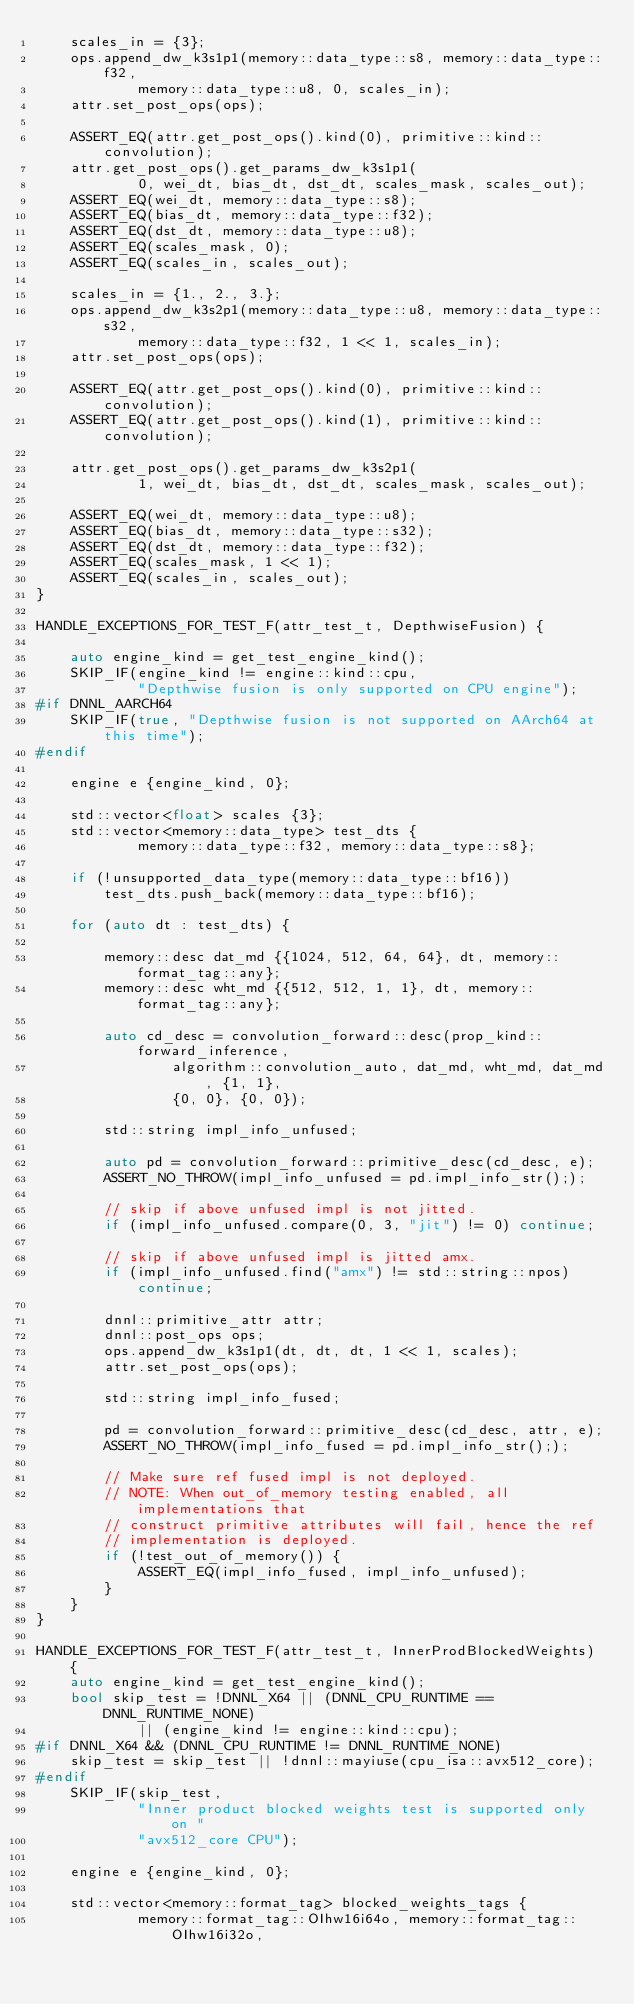Convert code to text. <code><loc_0><loc_0><loc_500><loc_500><_C++_>    scales_in = {3};
    ops.append_dw_k3s1p1(memory::data_type::s8, memory::data_type::f32,
            memory::data_type::u8, 0, scales_in);
    attr.set_post_ops(ops);

    ASSERT_EQ(attr.get_post_ops().kind(0), primitive::kind::convolution);
    attr.get_post_ops().get_params_dw_k3s1p1(
            0, wei_dt, bias_dt, dst_dt, scales_mask, scales_out);
    ASSERT_EQ(wei_dt, memory::data_type::s8);
    ASSERT_EQ(bias_dt, memory::data_type::f32);
    ASSERT_EQ(dst_dt, memory::data_type::u8);
    ASSERT_EQ(scales_mask, 0);
    ASSERT_EQ(scales_in, scales_out);

    scales_in = {1., 2., 3.};
    ops.append_dw_k3s2p1(memory::data_type::u8, memory::data_type::s32,
            memory::data_type::f32, 1 << 1, scales_in);
    attr.set_post_ops(ops);

    ASSERT_EQ(attr.get_post_ops().kind(0), primitive::kind::convolution);
    ASSERT_EQ(attr.get_post_ops().kind(1), primitive::kind::convolution);

    attr.get_post_ops().get_params_dw_k3s2p1(
            1, wei_dt, bias_dt, dst_dt, scales_mask, scales_out);

    ASSERT_EQ(wei_dt, memory::data_type::u8);
    ASSERT_EQ(bias_dt, memory::data_type::s32);
    ASSERT_EQ(dst_dt, memory::data_type::f32);
    ASSERT_EQ(scales_mask, 1 << 1);
    ASSERT_EQ(scales_in, scales_out);
}

HANDLE_EXCEPTIONS_FOR_TEST_F(attr_test_t, DepthwiseFusion) {

    auto engine_kind = get_test_engine_kind();
    SKIP_IF(engine_kind != engine::kind::cpu,
            "Depthwise fusion is only supported on CPU engine");
#if DNNL_AARCH64
    SKIP_IF(true, "Depthwise fusion is not supported on AArch64 at this time");
#endif

    engine e {engine_kind, 0};

    std::vector<float> scales {3};
    std::vector<memory::data_type> test_dts {
            memory::data_type::f32, memory::data_type::s8};

    if (!unsupported_data_type(memory::data_type::bf16))
        test_dts.push_back(memory::data_type::bf16);

    for (auto dt : test_dts) {

        memory::desc dat_md {{1024, 512, 64, 64}, dt, memory::format_tag::any};
        memory::desc wht_md {{512, 512, 1, 1}, dt, memory::format_tag::any};

        auto cd_desc = convolution_forward::desc(prop_kind::forward_inference,
                algorithm::convolution_auto, dat_md, wht_md, dat_md, {1, 1},
                {0, 0}, {0, 0});

        std::string impl_info_unfused;

        auto pd = convolution_forward::primitive_desc(cd_desc, e);
        ASSERT_NO_THROW(impl_info_unfused = pd.impl_info_str(););

        // skip if above unfused impl is not jitted.
        if (impl_info_unfused.compare(0, 3, "jit") != 0) continue;

        // skip if above unfused impl is jitted amx.
        if (impl_info_unfused.find("amx") != std::string::npos) continue;

        dnnl::primitive_attr attr;
        dnnl::post_ops ops;
        ops.append_dw_k3s1p1(dt, dt, dt, 1 << 1, scales);
        attr.set_post_ops(ops);

        std::string impl_info_fused;

        pd = convolution_forward::primitive_desc(cd_desc, attr, e);
        ASSERT_NO_THROW(impl_info_fused = pd.impl_info_str(););

        // Make sure ref fused impl is not deployed.
        // NOTE: When out_of_memory testing enabled, all implementations that
        // construct primitive attributes will fail, hence the ref
        // implementation is deployed.
        if (!test_out_of_memory()) {
            ASSERT_EQ(impl_info_fused, impl_info_unfused);
        }
    }
}

HANDLE_EXCEPTIONS_FOR_TEST_F(attr_test_t, InnerProdBlockedWeights) {
    auto engine_kind = get_test_engine_kind();
    bool skip_test = !DNNL_X64 || (DNNL_CPU_RUNTIME == DNNL_RUNTIME_NONE)
            || (engine_kind != engine::kind::cpu);
#if DNNL_X64 && (DNNL_CPU_RUNTIME != DNNL_RUNTIME_NONE)
    skip_test = skip_test || !dnnl::mayiuse(cpu_isa::avx512_core);
#endif
    SKIP_IF(skip_test,
            "Inner product blocked weights test is supported only on "
            "avx512_core CPU");

    engine e {engine_kind, 0};

    std::vector<memory::format_tag> blocked_weights_tags {
            memory::format_tag::OIhw16i64o, memory::format_tag::OIhw16i32o,</code> 